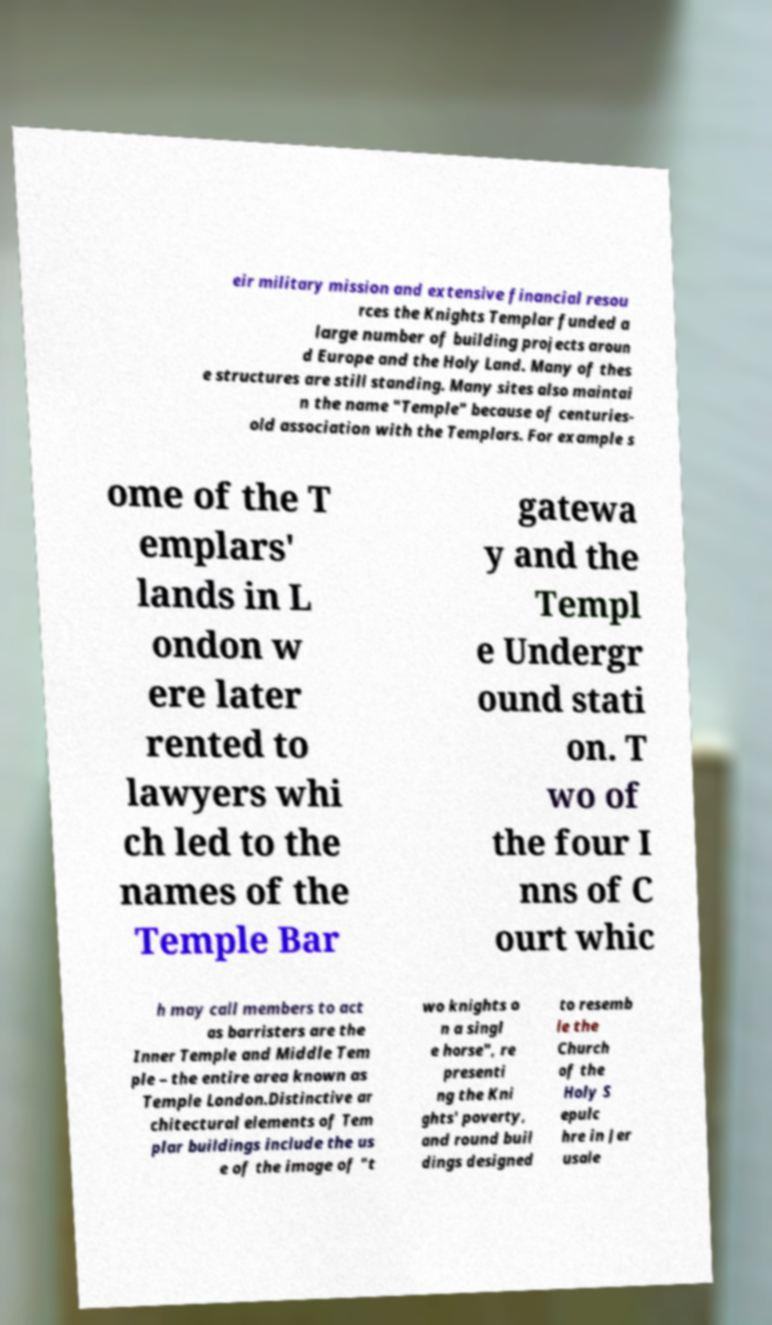Could you extract and type out the text from this image? eir military mission and extensive financial resou rces the Knights Templar funded a large number of building projects aroun d Europe and the Holy Land. Many of thes e structures are still standing. Many sites also maintai n the name "Temple" because of centuries- old association with the Templars. For example s ome of the T emplars' lands in L ondon w ere later rented to lawyers whi ch led to the names of the Temple Bar gatewa y and the Templ e Undergr ound stati on. T wo of the four I nns of C ourt whic h may call members to act as barristers are the Inner Temple and Middle Tem ple – the entire area known as Temple London.Distinctive ar chitectural elements of Tem plar buildings include the us e of the image of "t wo knights o n a singl e horse", re presenti ng the Kni ghts' poverty, and round buil dings designed to resemb le the Church of the Holy S epulc hre in Jer usale 